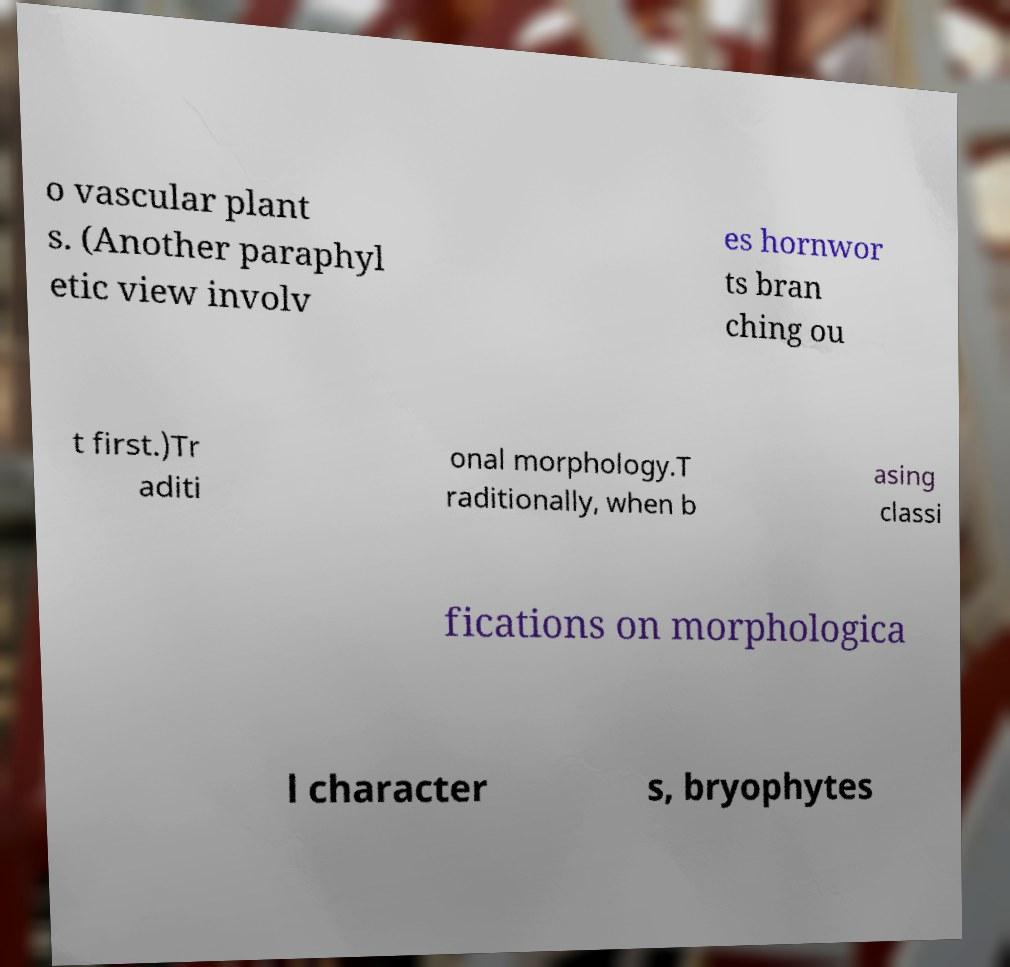I need the written content from this picture converted into text. Can you do that? o vascular plant s. (Another paraphyl etic view involv es hornwor ts bran ching ou t first.)Tr aditi onal morphology.T raditionally, when b asing classi fications on morphologica l character s, bryophytes 